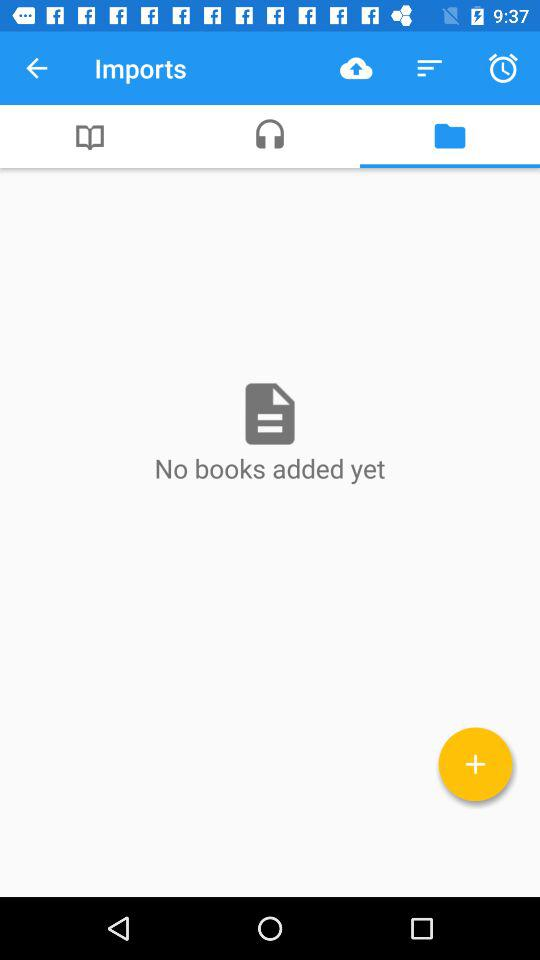How many books are added? There are no books added. 